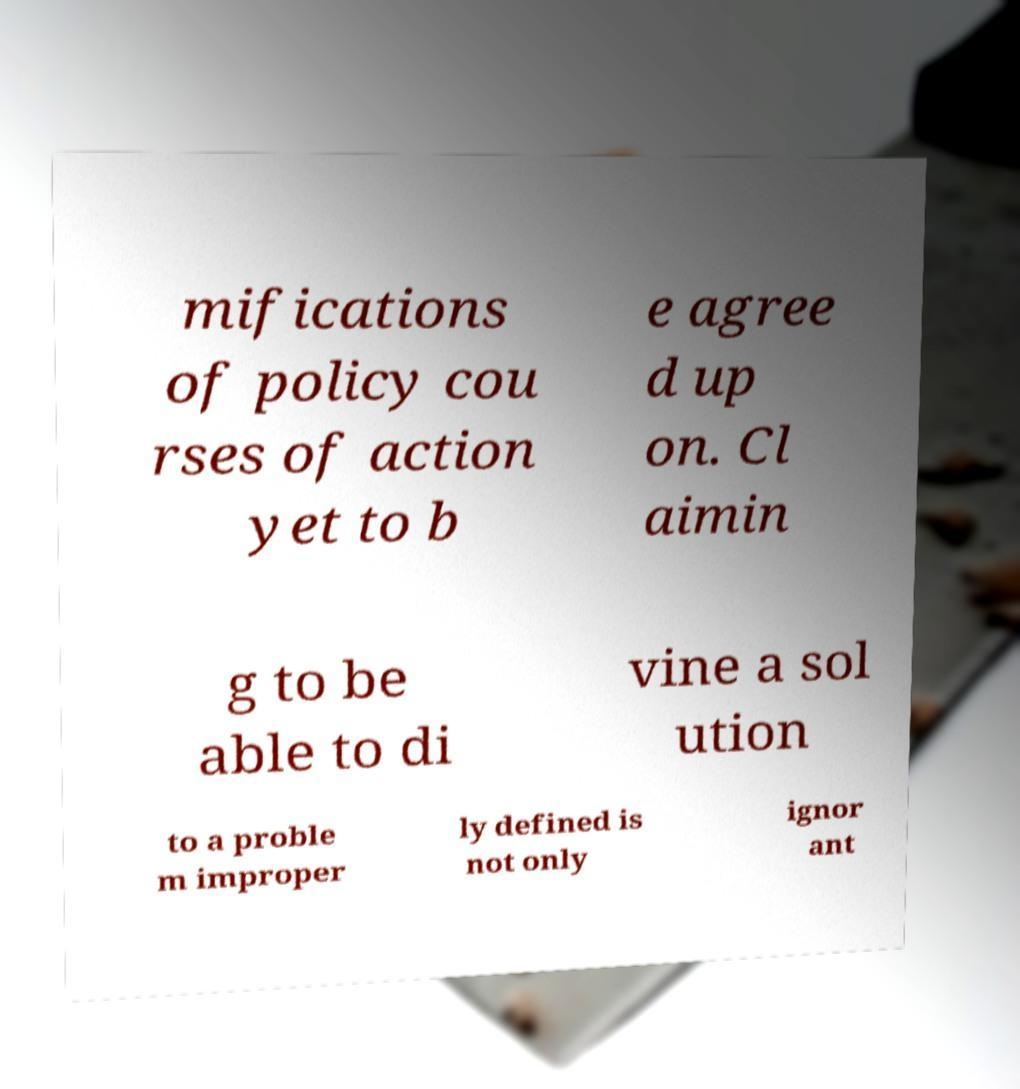For documentation purposes, I need the text within this image transcribed. Could you provide that? mifications of policy cou rses of action yet to b e agree d up on. Cl aimin g to be able to di vine a sol ution to a proble m improper ly defined is not only ignor ant 